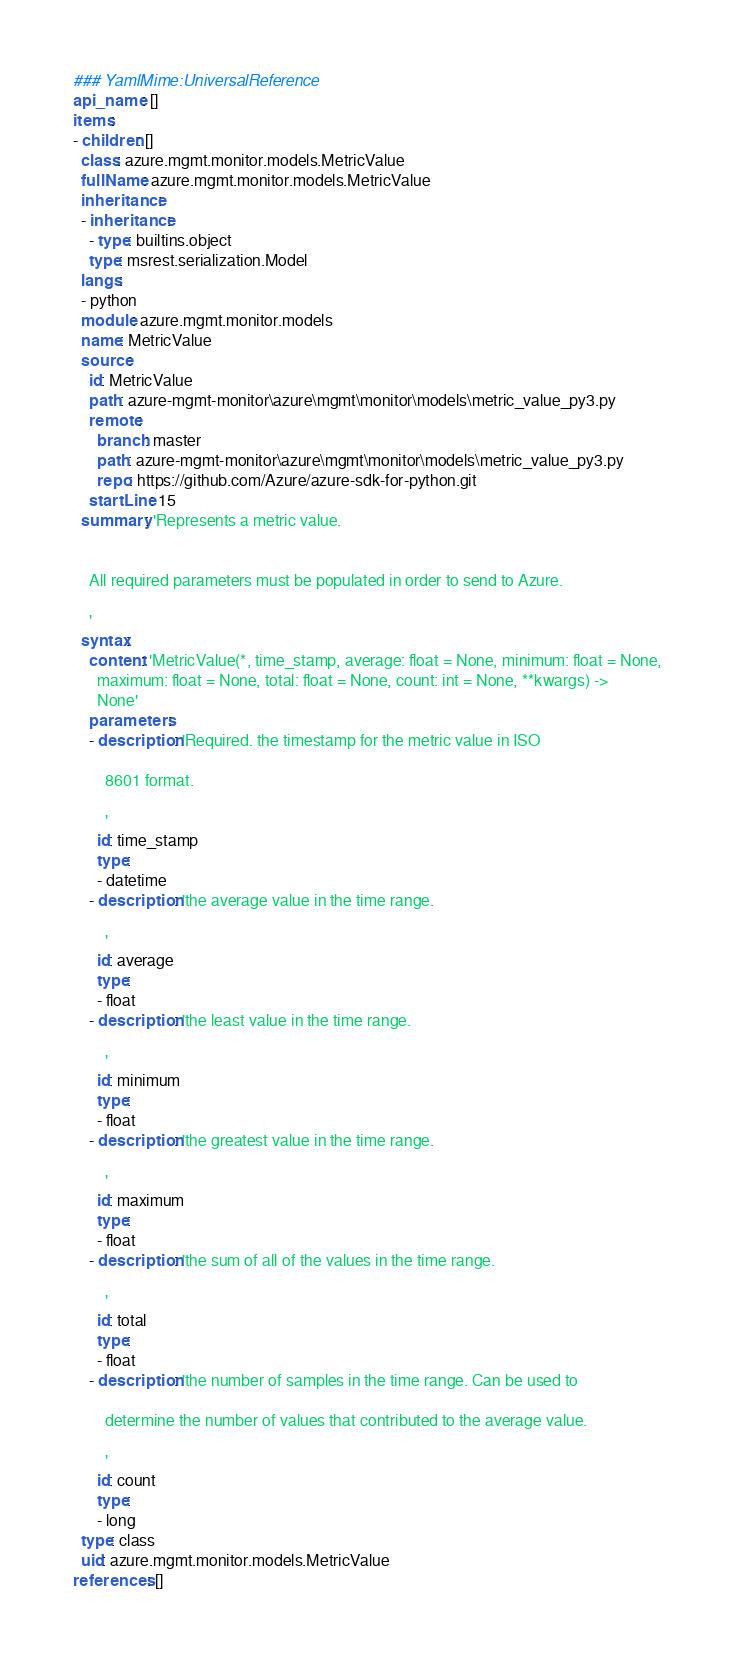Convert code to text. <code><loc_0><loc_0><loc_500><loc_500><_YAML_>### YamlMime:UniversalReference
api_name: []
items:
- children: []
  class: azure.mgmt.monitor.models.MetricValue
  fullName: azure.mgmt.monitor.models.MetricValue
  inheritance:
  - inheritance:
    - type: builtins.object
    type: msrest.serialization.Model
  langs:
  - python
  module: azure.mgmt.monitor.models
  name: MetricValue
  source:
    id: MetricValue
    path: azure-mgmt-monitor\azure\mgmt\monitor\models\metric_value_py3.py
    remote:
      branch: master
      path: azure-mgmt-monitor\azure\mgmt\monitor\models\metric_value_py3.py
      repo: https://github.com/Azure/azure-sdk-for-python.git
    startLine: 15
  summary: 'Represents a metric value.


    All required parameters must be populated in order to send to Azure.

    '
  syntax:
    content: 'MetricValue(*, time_stamp, average: float = None, minimum: float = None,
      maximum: float = None, total: float = None, count: int = None, **kwargs) ->
      None'
    parameters:
    - description: 'Required. the timestamp for the metric value in ISO

        8601 format.

        '
      id: time_stamp
      type:
      - datetime
    - description: 'the average value in the time range.

        '
      id: average
      type:
      - float
    - description: 'the least value in the time range.

        '
      id: minimum
      type:
      - float
    - description: 'the greatest value in the time range.

        '
      id: maximum
      type:
      - float
    - description: 'the sum of all of the values in the time range.

        '
      id: total
      type:
      - float
    - description: 'the number of samples in the time range. Can be used to

        determine the number of values that contributed to the average value.

        '
      id: count
      type:
      - long
  type: class
  uid: azure.mgmt.monitor.models.MetricValue
references: []
</code> 